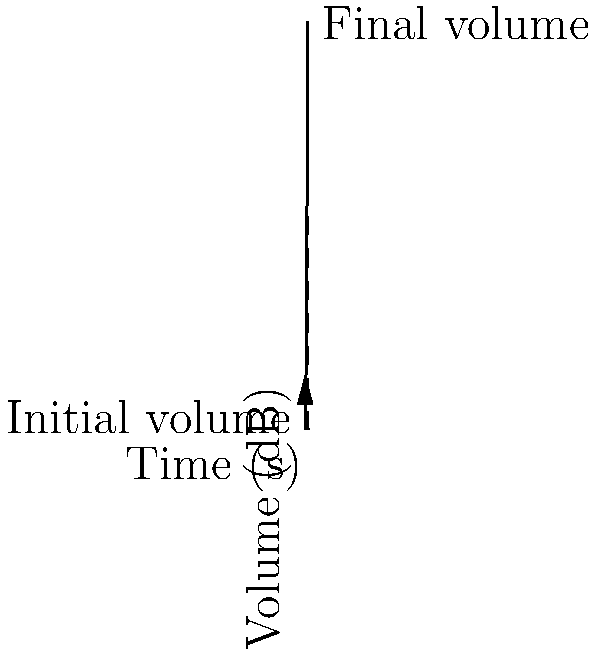In a musical piece, a crescendo is represented by a vector in time-volume space. The initial volume is 20 dB, and after 4 seconds, it reaches 80 dB. What is the magnitude of this vector, representing the total change in volume over time? To determine the magnitude of the vector representing the volume change in a crescendo, we need to follow these steps:

1) Identify the components of the vector:
   - Time component (x): 4 seconds
   - Volume component (y): 80 dB - 20 dB = 60 dB

2) The vector can be represented as $\vec{v} = (4, 60)$

3) To calculate the magnitude of this vector, we use the Pythagorean theorem:
   $\text{Magnitude} = \sqrt{x^2 + y^2}$

4) Substituting our values:
   $\text{Magnitude} = \sqrt{4^2 + 60^2}$

5) Simplify:
   $\text{Magnitude} = \sqrt{16 + 3600} = \sqrt{3616}$

6) Calculate the square root:
   $\text{Magnitude} \approx 60.13$

Therefore, the magnitude of the vector representing the volume change in the crescendo is approximately 60.13 units in this time-volume space.
Answer: $60.13$ units 